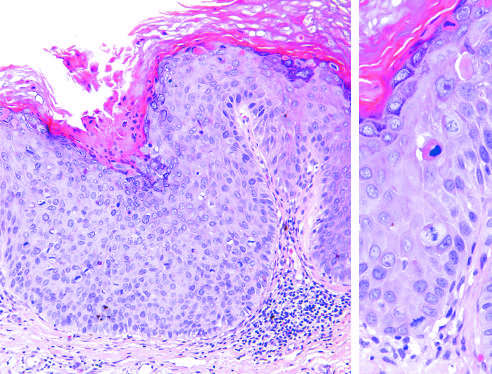does the epithelium above the intact basement membrane show delayed maturation and disorganization?
Answer the question using a single word or phrase. Yes 